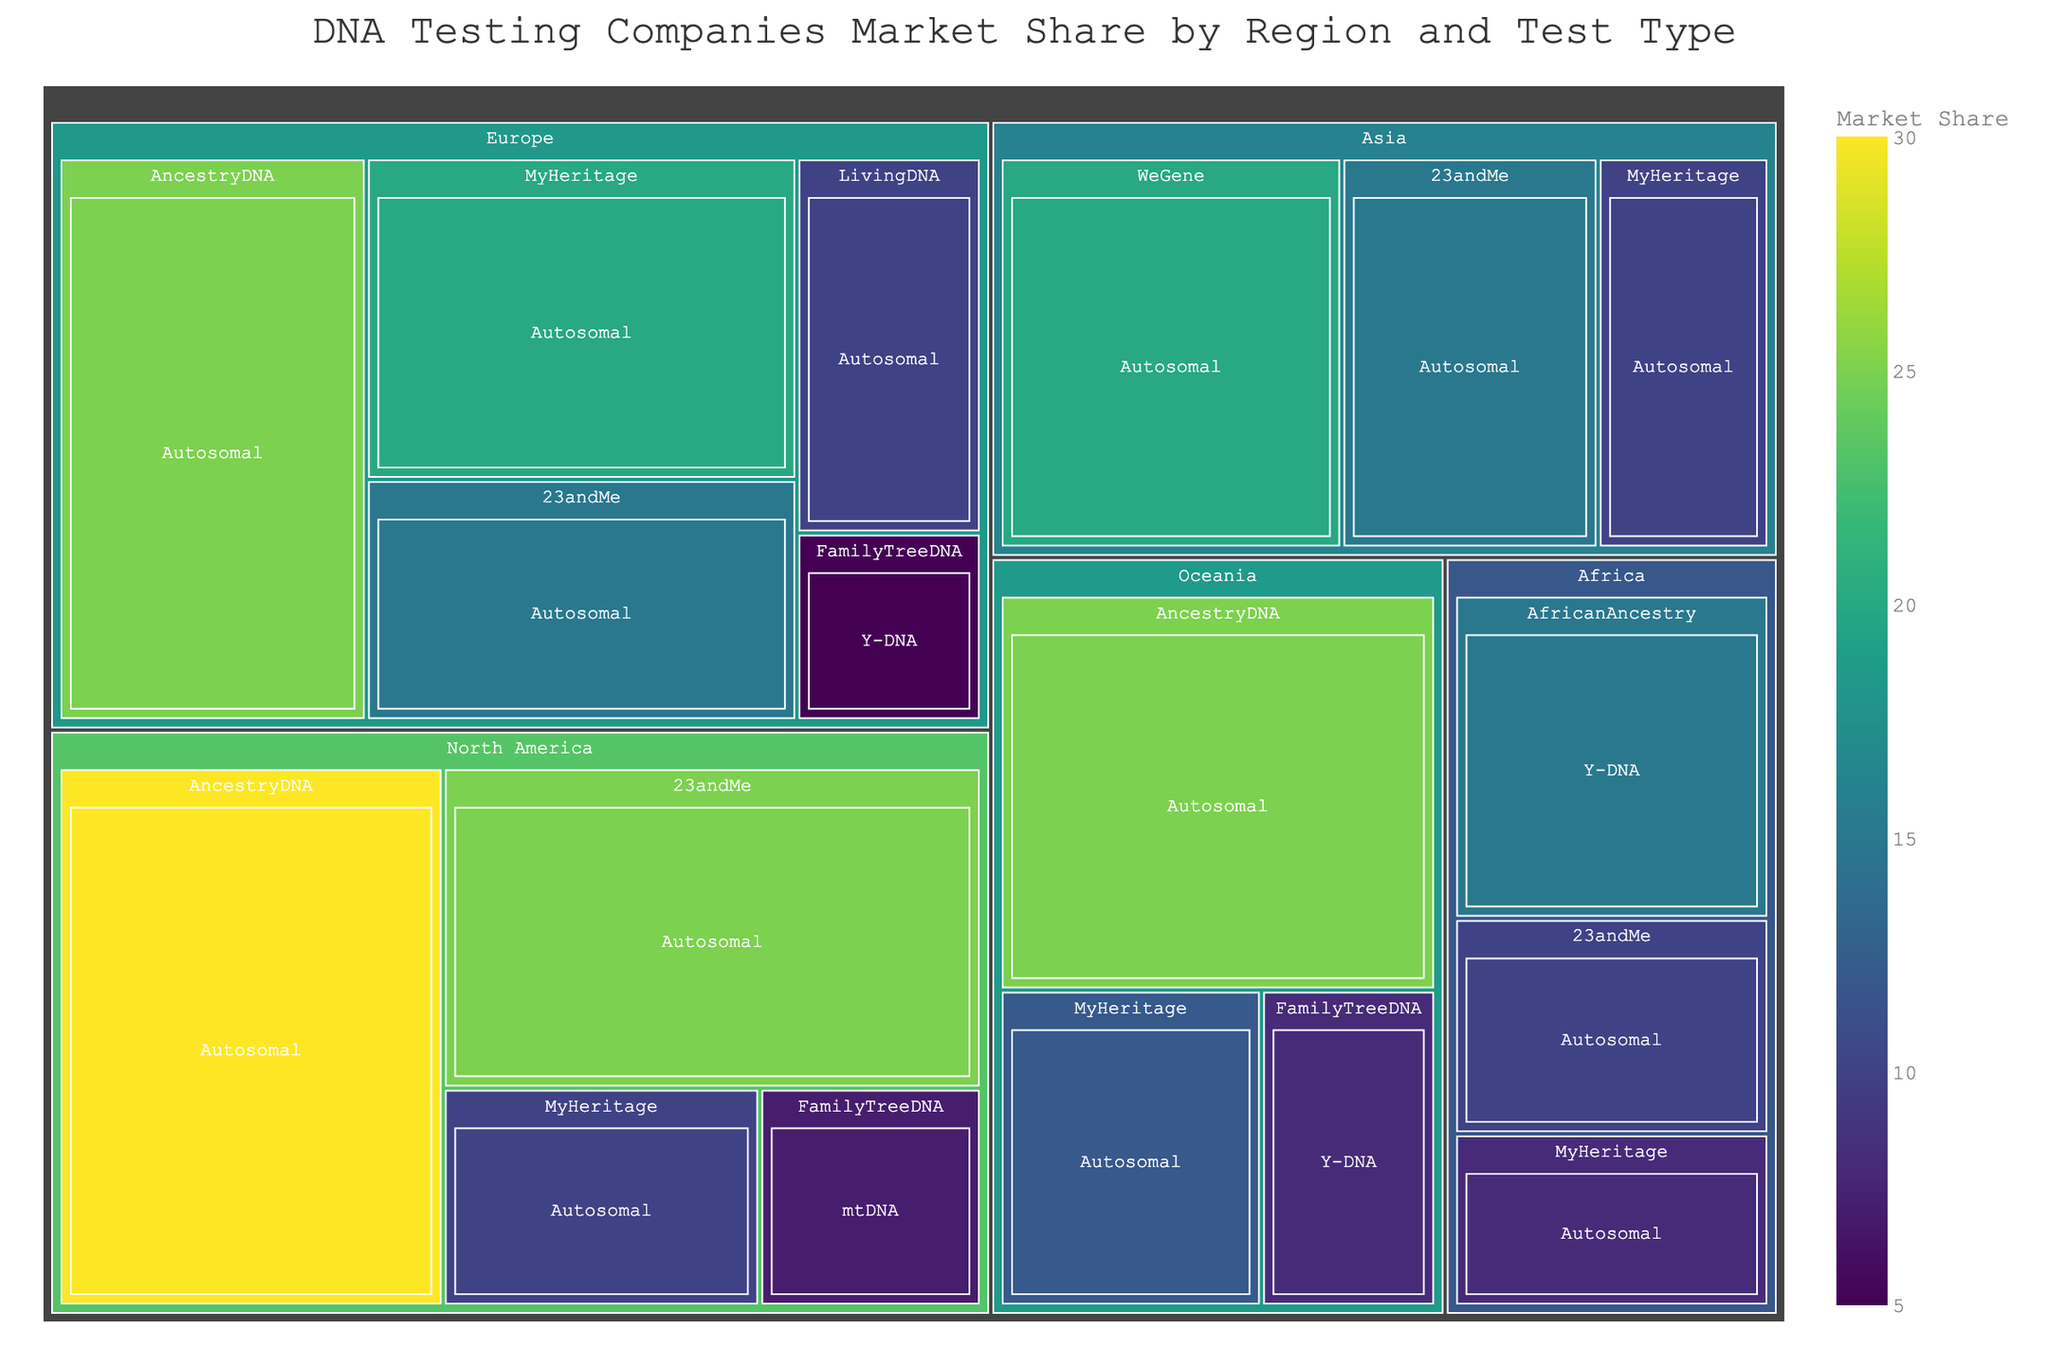How many regions are displayed in the Treemap? The Treemap is organized by regions and each top-level segment represents a different region. Count the regions shown.
Answer: 5 Which company has the largest market share in Europe? To find the largest market share in Europe, examine the segments within the Europe region and identify the company with the biggest segment.
Answer: AncestryDNA What is the total market share of MyHeritage across all regions? Sum up the market shares of MyHeritage in each region: Europe (20%) + North America (10%) + Asia (10%) + Oceania (12%) + Africa (8%).
Answer: 60% Which company provides the highest number of different test types? To find out which company offers the most test types, look at the company segments and count the different test types within each company.
Answer: FamilyTreeDNA What is the dominant test type in North America? In the North America segment, examine the types of tests offered and determine which test type has the majority of the market share.
Answer: Autosomal Compare the market share of AncestryDNA and 23andMe in the Oceania region. Look at the Oceania segment and compare the market shares of AncestryDNA (25%) and 23andMe (not present).
Answer: AncestryDNA (25%), 23andMe (0%) Which region has the smallest total market share for Y-DNA tests? Find all segments labeled "Y-DNA" and sum the market shares for each region. The region with the smallest sum has the smallest market share for Y-DNA tests.
Answer: Europe How does the distribution of market share in Asia differ from Europe? Compare the sizes of the company segments in the Asia and Europe regions to discuss differences in market share distribution.
Answer: Higher market share for WeGene in Asia, higher for AncestryDNA and MyHeritage in Europe What's the average market share of autosomal tests within the Europe region? Add the market shares of autosomal tests in Europe (25% + 20% + 15% + 10%) and divide by the number of autosomal tests (4).
Answer: 17.5% Which company has a presence in the most regions? Count the appearances of each company across different regions to see which company is present in the most regions.
Answer: MyHeritage 